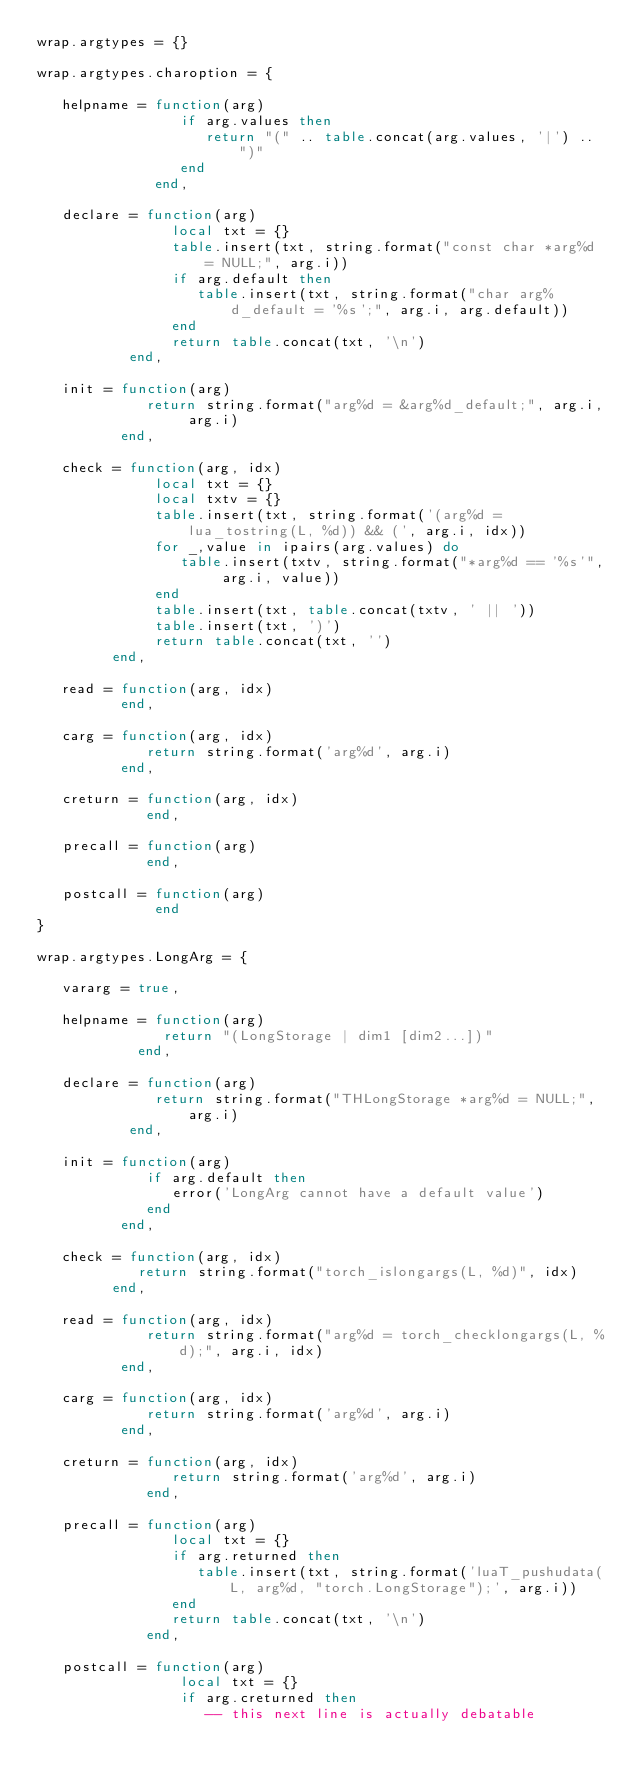Convert code to text. <code><loc_0><loc_0><loc_500><loc_500><_Lua_>wrap.argtypes = {}

wrap.argtypes.charoption = {
   
   helpname = function(arg)
                 if arg.values then
                    return "(" .. table.concat(arg.values, '|') .. ")"
                 end
              end,

   declare = function(arg)
                local txt = {}
                table.insert(txt, string.format("const char *arg%d = NULL;", arg.i))
                if arg.default then
                   table.insert(txt, string.format("char arg%d_default = '%s';", arg.i, arg.default))
                end
                return table.concat(txt, '\n')
           end,

   init = function(arg)
             return string.format("arg%d = &arg%d_default;", arg.i, arg.i)
          end,
   
   check = function(arg, idx)
              local txt = {}
              local txtv = {}
              table.insert(txt, string.format('(arg%d = lua_tostring(L, %d)) && (', arg.i, idx))
              for _,value in ipairs(arg.values) do
                 table.insert(txtv, string.format("*arg%d == '%s'", arg.i, value))
              end
              table.insert(txt, table.concat(txtv, ' || '))
              table.insert(txt, ')')              
              return table.concat(txt, '')
         end,

   read = function(arg, idx)
          end,
   
   carg = function(arg, idx)
             return string.format('arg%d', arg.i)
          end,

   creturn = function(arg, idx)
             end,
   
   precall = function(arg)
             end,

   postcall = function(arg)
              end   
}

wrap.argtypes.LongArg = {

   vararg = true,

   helpname = function(arg)
               return "(LongStorage | dim1 [dim2...])"
            end,

   declare = function(arg)
              return string.format("THLongStorage *arg%d = NULL;", arg.i)
           end,

   init = function(arg)
             if arg.default then
                error('LongArg cannot have a default value')
             end
          end,
   
   check = function(arg, idx)
            return string.format("torch_islongargs(L, %d)", idx)
         end,

   read = function(arg, idx)
             return string.format("arg%d = torch_checklongargs(L, %d);", arg.i, idx)
          end,
   
   carg = function(arg, idx)
             return string.format('arg%d', arg.i)
          end,

   creturn = function(arg, idx)
                return string.format('arg%d', arg.i)
             end,
   
   precall = function(arg)
                local txt = {}
                if arg.returned then
                   table.insert(txt, string.format('luaT_pushudata(L, arg%d, "torch.LongStorage");', arg.i))
                end
                return table.concat(txt, '\n')
             end,

   postcall = function(arg)
                 local txt = {}
                 if arg.creturned then
                    -- this next line is actually debatable</code> 